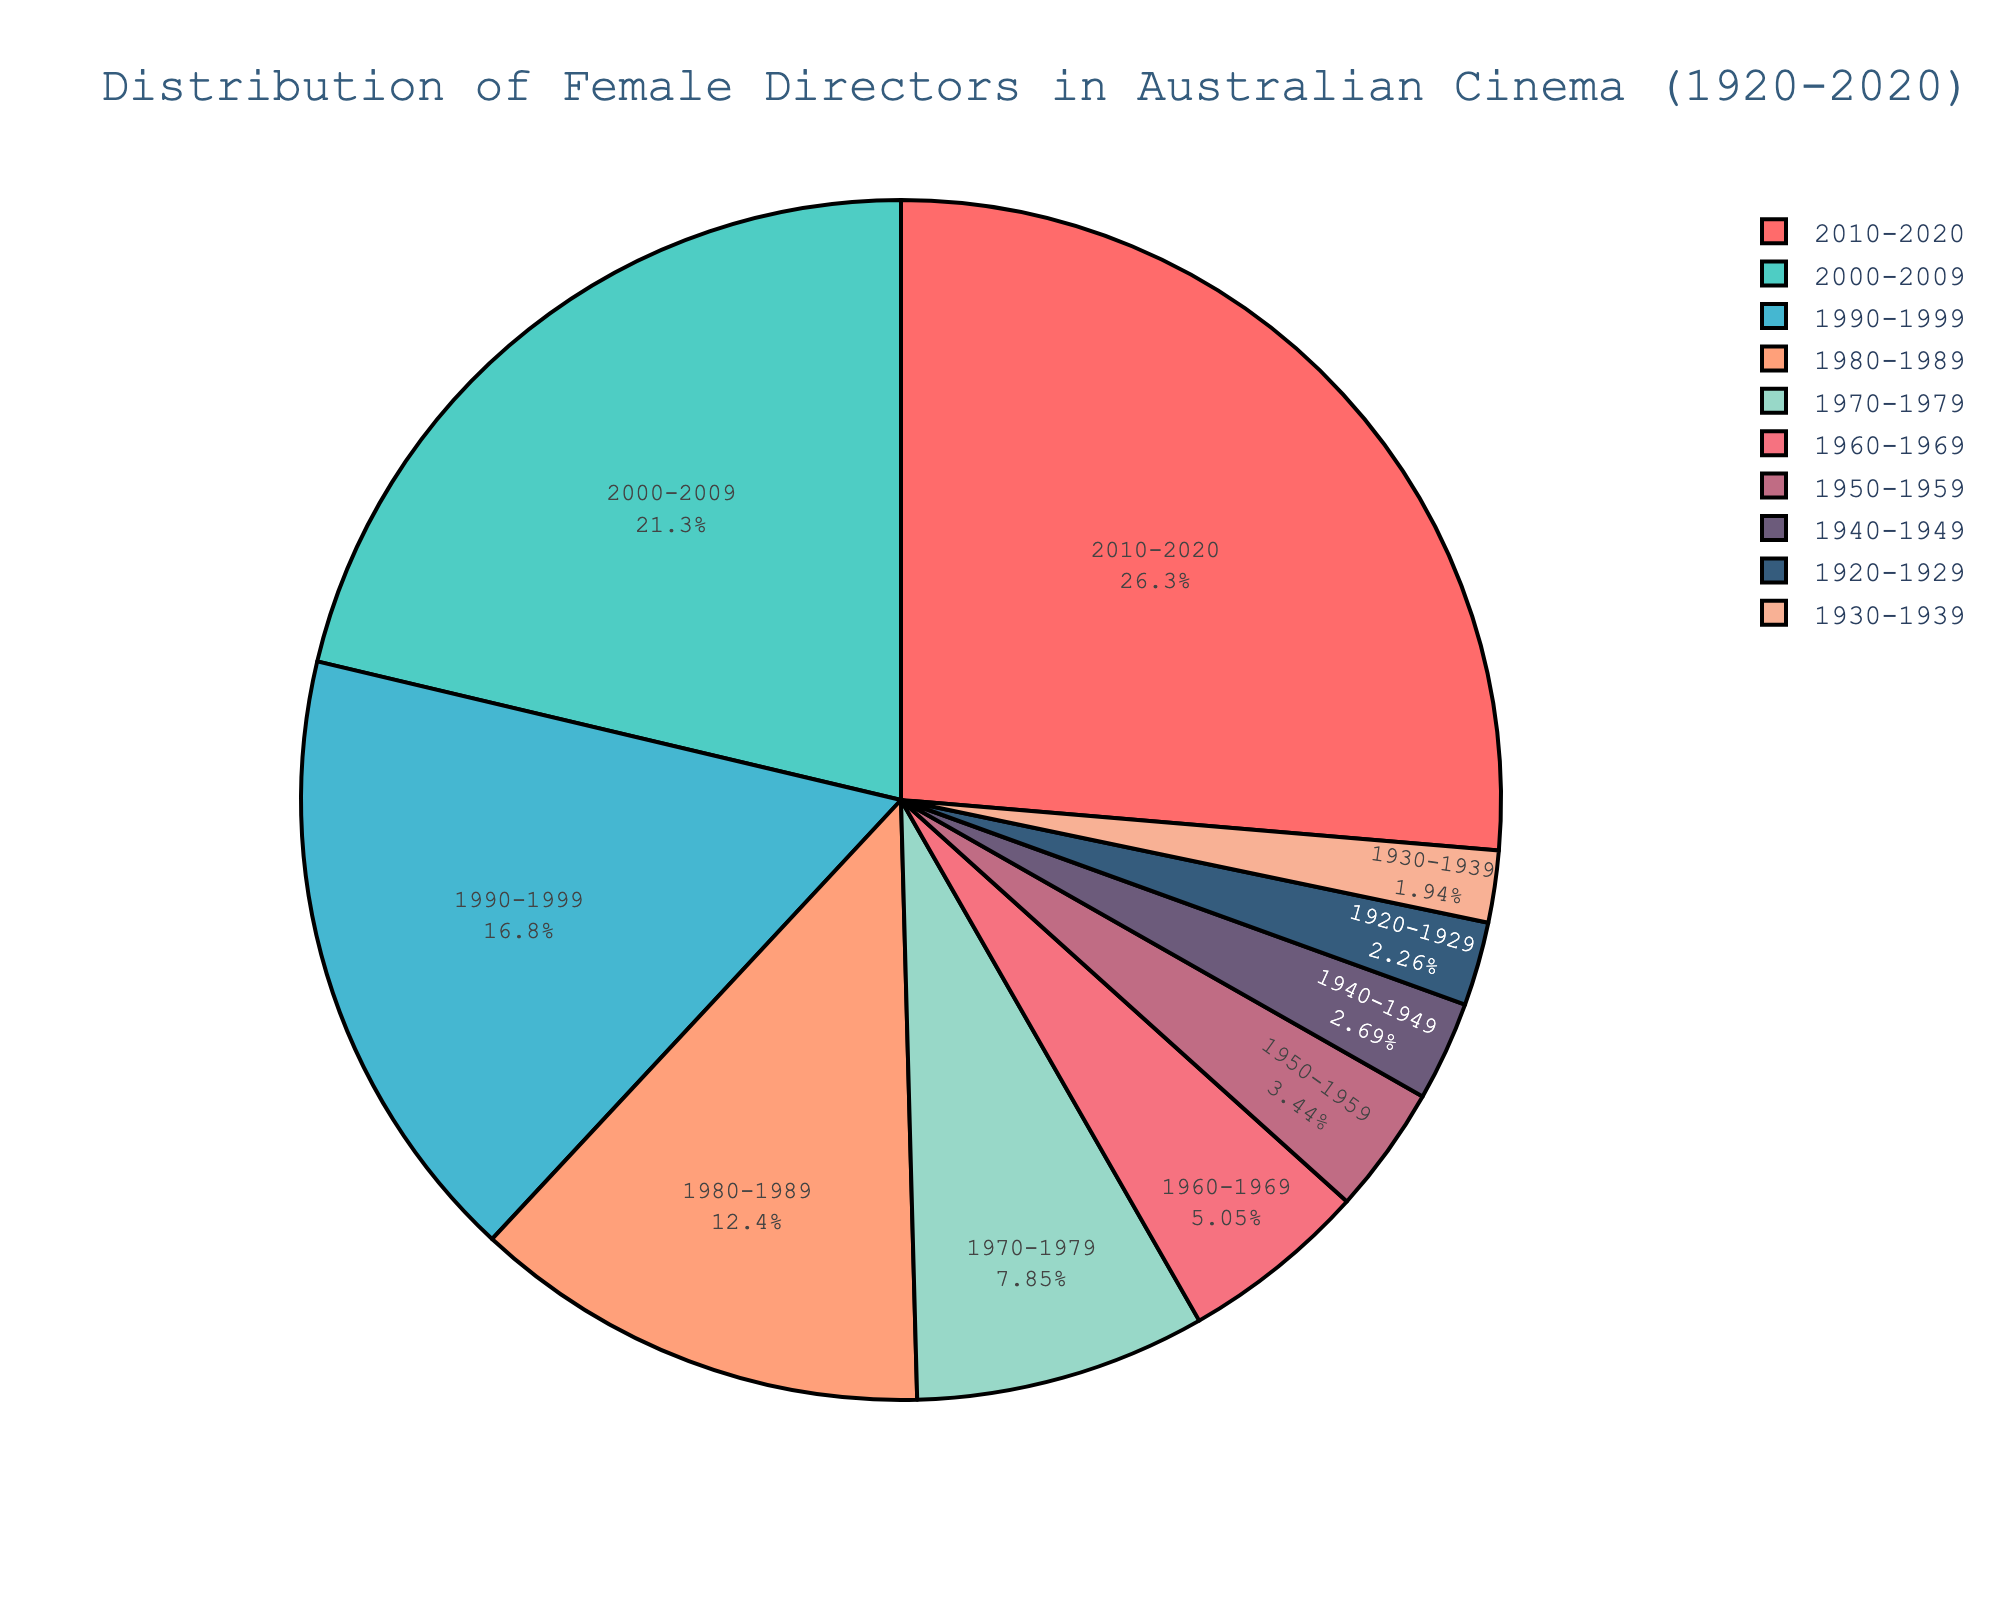What decade saw the highest percentage of female directors in Australian cinema? The figure shows the distribution of female directors by decade. The slice labeled "2010-2020" is largest and has the highest percentage label.
Answer: 2010-2020 How much did the percentage of female directors increase from the 1950s to the 2010s? In 1950-1959, the percentage was 3.2%. In 2010-2020, it was 24.5%. The increase is 24.5% - 3.2% = 21.3%.
Answer: 21.3% Which decade had a lower percentage of female directors, the 1930s or the 1940s? The slice labeled "1930-1939" has a percentage of 1.8%, while the one labeled "1940-1949" has 2.5%. 1.8% is lower than 2.5%.
Answer: 1930s What is the total percentage of female directors in Australian cinema from 1920-1969? Summing the percentages from 1920 to 1969: 2.1% + 1.8% + 2.5% + 3.2% + 4.7% = 14.3%.
Answer: 14.3% How does the percentage of female directors in the 1980s compare to that of the 2000s? The percentage in the 1980s is 11.5%, and in the 2000s it is 19.8%. 19.8% is higher than 11.5%.
Answer: Higher in the 2000s What are the colors used to represent the decades from 1970-2020 in the pie chart? The colors are shown with each decade: 1970-1979 (brown), 1980-1989 (light green), 1990-1999 (purple), 2000-2009 (red), 2010-2020 (blue).
Answer: brown, light green, purple, red, blue Which decade had a slightly higher percentage of female directors, the 1920s or the 1950s? The pie chart shows 2.1% for the 1920s and 3.2% for the 1950s. 3.2% is higher than 2.1%.
Answer: 1950s 